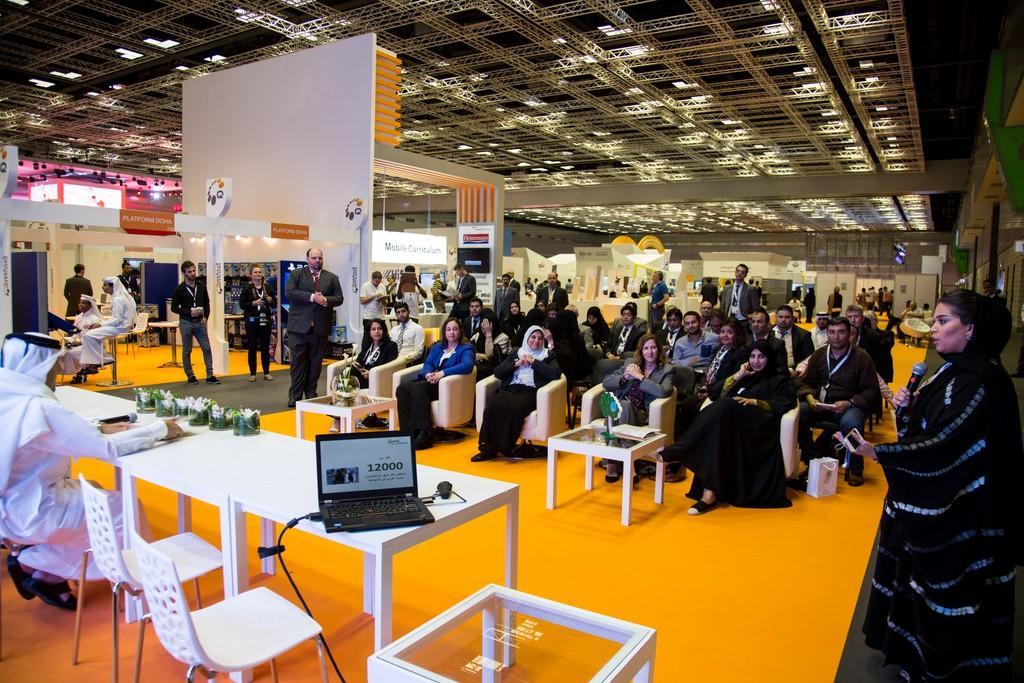In one or two sentences, can you explain what this image depicts? Here we can see some persons are sitting on the chairs. These are the tables. On the table there is a laptop, and a mike. This is floor. Here we can see some persons are standing on the floor. There is a woman who is talking on the mike. In the background we can see boards. This is roof and these are the lights. 